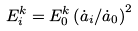Convert formula to latex. <formula><loc_0><loc_0><loc_500><loc_500>E _ { i } ^ { k } = E _ { 0 } ^ { k } \left ( \dot { a } _ { i } / \dot { a } _ { 0 } \right ) ^ { 2 }</formula> 